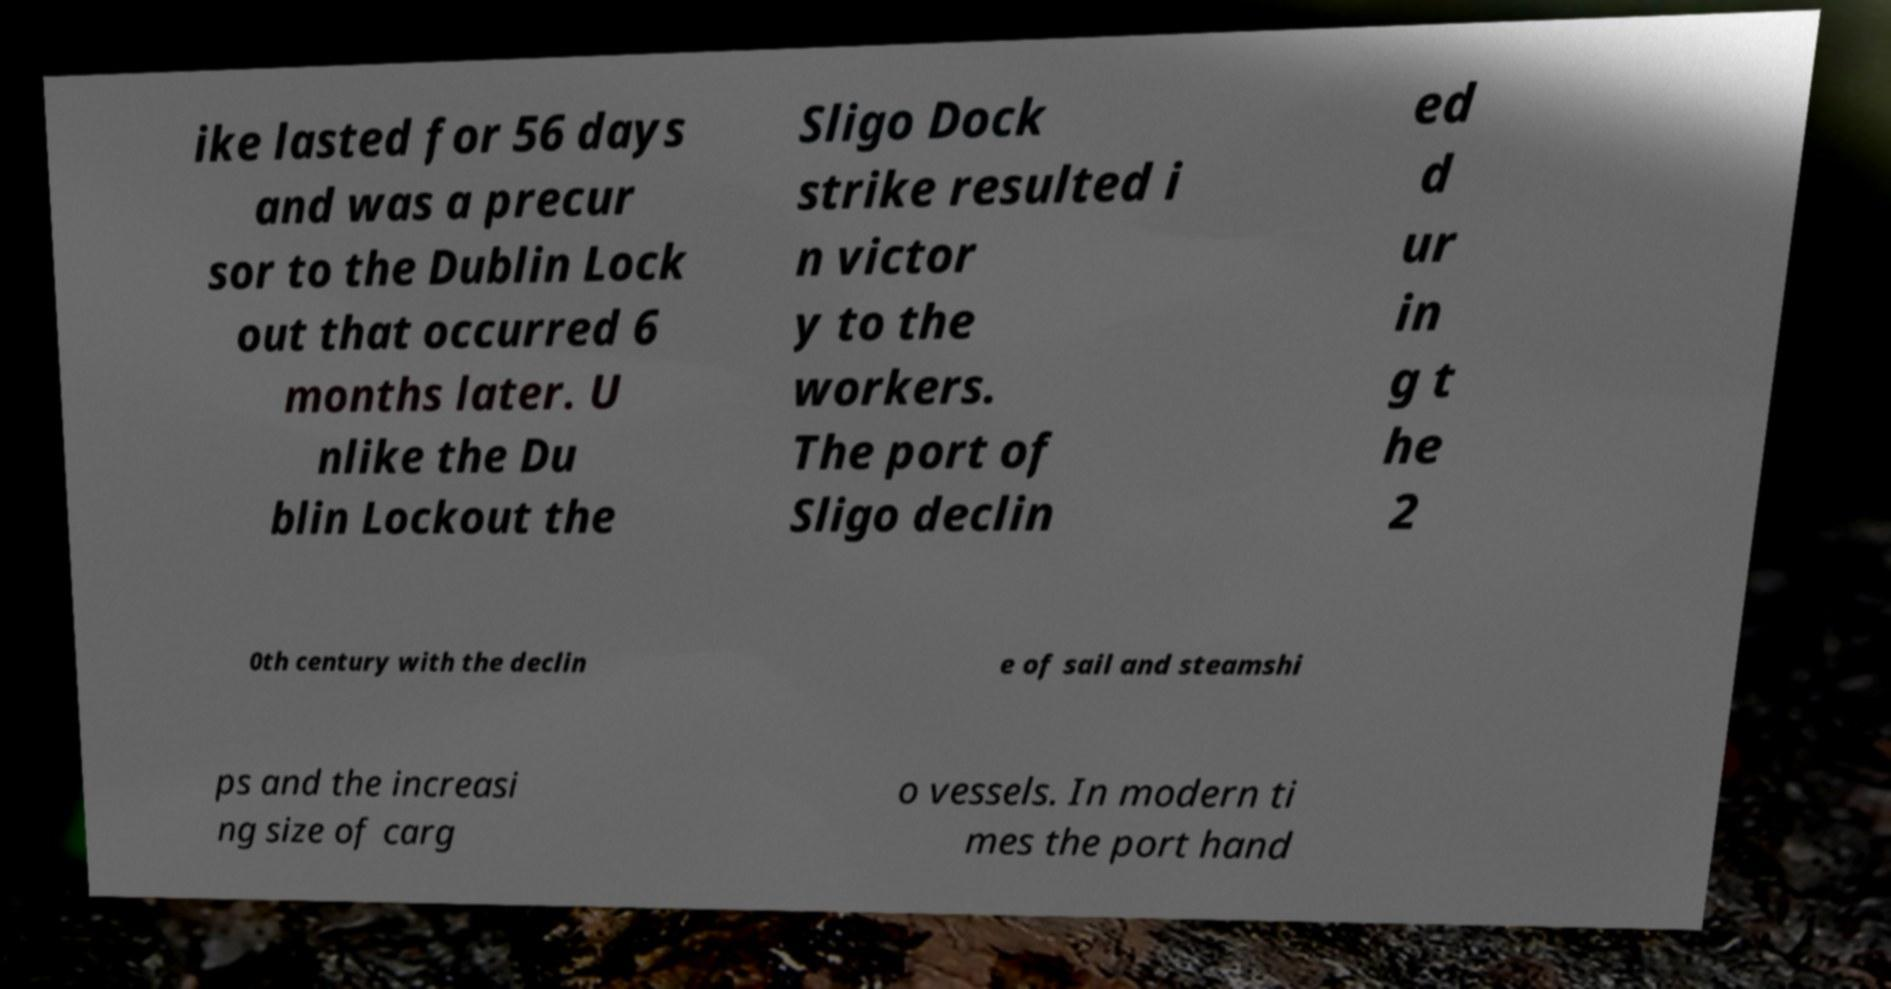Can you read and provide the text displayed in the image?This photo seems to have some interesting text. Can you extract and type it out for me? ike lasted for 56 days and was a precur sor to the Dublin Lock out that occurred 6 months later. U nlike the Du blin Lockout the Sligo Dock strike resulted i n victor y to the workers. The port of Sligo declin ed d ur in g t he 2 0th century with the declin e of sail and steamshi ps and the increasi ng size of carg o vessels. In modern ti mes the port hand 